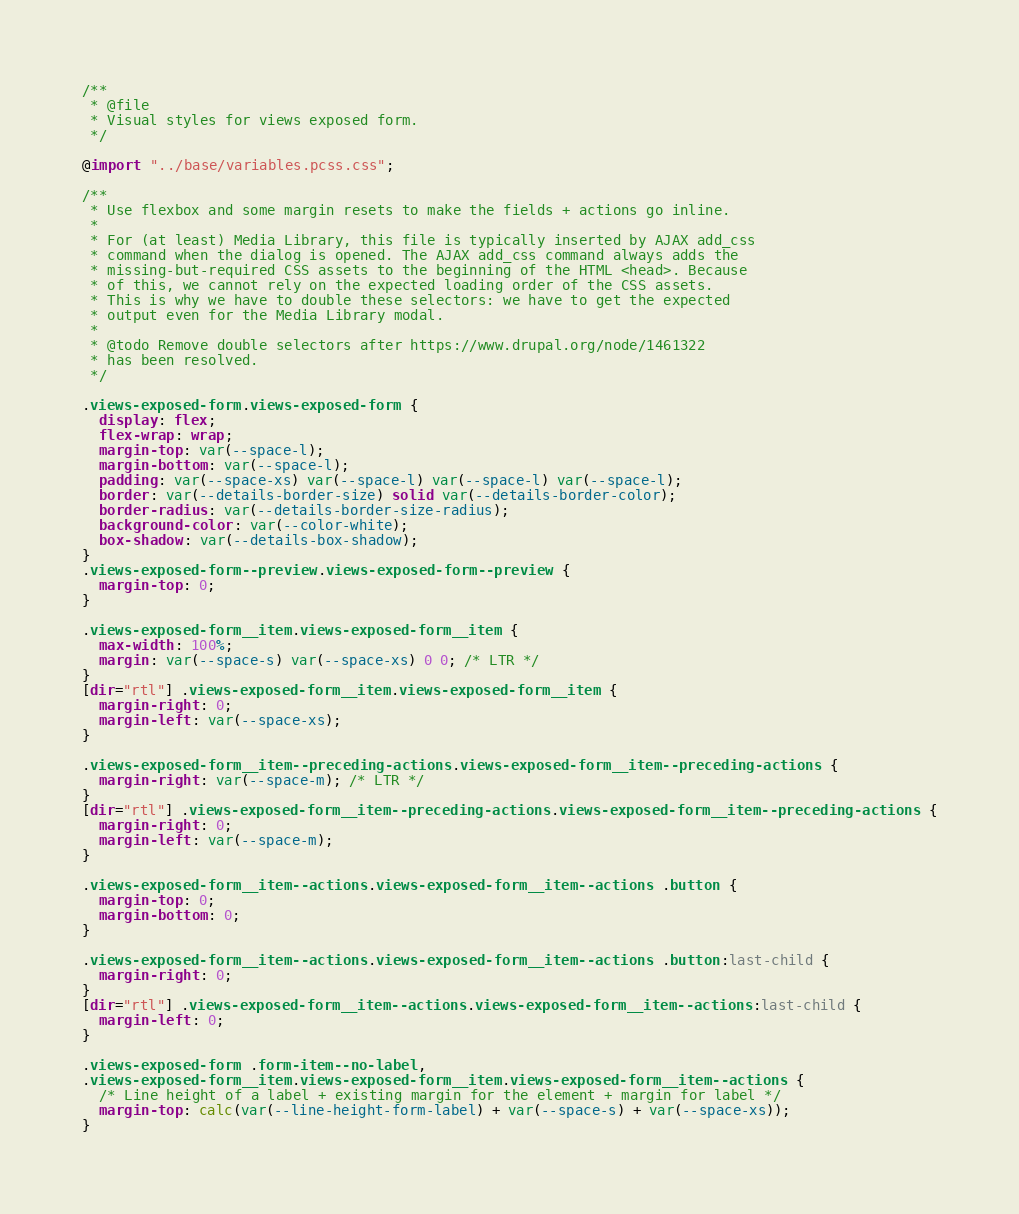<code> <loc_0><loc_0><loc_500><loc_500><_CSS_>/**
 * @file
 * Visual styles for views exposed form.
 */

@import "../base/variables.pcss.css";

/**
 * Use flexbox and some margin resets to make the fields + actions go inline.
 *
 * For (at least) Media Library, this file is typically inserted by AJAX add_css
 * command when the dialog is opened. The AJAX add_css command always adds the
 * missing-but-required CSS assets to the beginning of the HTML <head>. Because
 * of this, we cannot rely on the expected loading order of the CSS assets.
 * This is why we have to double these selectors: we have to get the expected
 * output even for the Media Library modal.
 *
 * @todo Remove double selectors after https://www.drupal.org/node/1461322
 * has been resolved.
 */

.views-exposed-form.views-exposed-form {
  display: flex;
  flex-wrap: wrap;
  margin-top: var(--space-l);
  margin-bottom: var(--space-l);
  padding: var(--space-xs) var(--space-l) var(--space-l) var(--space-l);
  border: var(--details-border-size) solid var(--details-border-color);
  border-radius: var(--details-border-size-radius);
  background-color: var(--color-white);
  box-shadow: var(--details-box-shadow);
}
.views-exposed-form--preview.views-exposed-form--preview {
  margin-top: 0;
}

.views-exposed-form__item.views-exposed-form__item {
  max-width: 100%;
  margin: var(--space-s) var(--space-xs) 0 0; /* LTR */
}
[dir="rtl"] .views-exposed-form__item.views-exposed-form__item {
  margin-right: 0;
  margin-left: var(--space-xs);
}

.views-exposed-form__item--preceding-actions.views-exposed-form__item--preceding-actions {
  margin-right: var(--space-m); /* LTR */
}
[dir="rtl"] .views-exposed-form__item--preceding-actions.views-exposed-form__item--preceding-actions {
  margin-right: 0;
  margin-left: var(--space-m);
}

.views-exposed-form__item--actions.views-exposed-form__item--actions .button {
  margin-top: 0;
  margin-bottom: 0;
}

.views-exposed-form__item--actions.views-exposed-form__item--actions .button:last-child {
  margin-right: 0;
}
[dir="rtl"] .views-exposed-form__item--actions.views-exposed-form__item--actions:last-child {
  margin-left: 0;
}

.views-exposed-form .form-item--no-label,
.views-exposed-form__item.views-exposed-form__item.views-exposed-form__item--actions {
  /* Line height of a label + existing margin for the element + margin for label */
  margin-top: calc(var(--line-height-form-label) + var(--space-s) + var(--space-xs));
}
</code> 